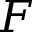<formula> <loc_0><loc_0><loc_500><loc_500>F</formula> 